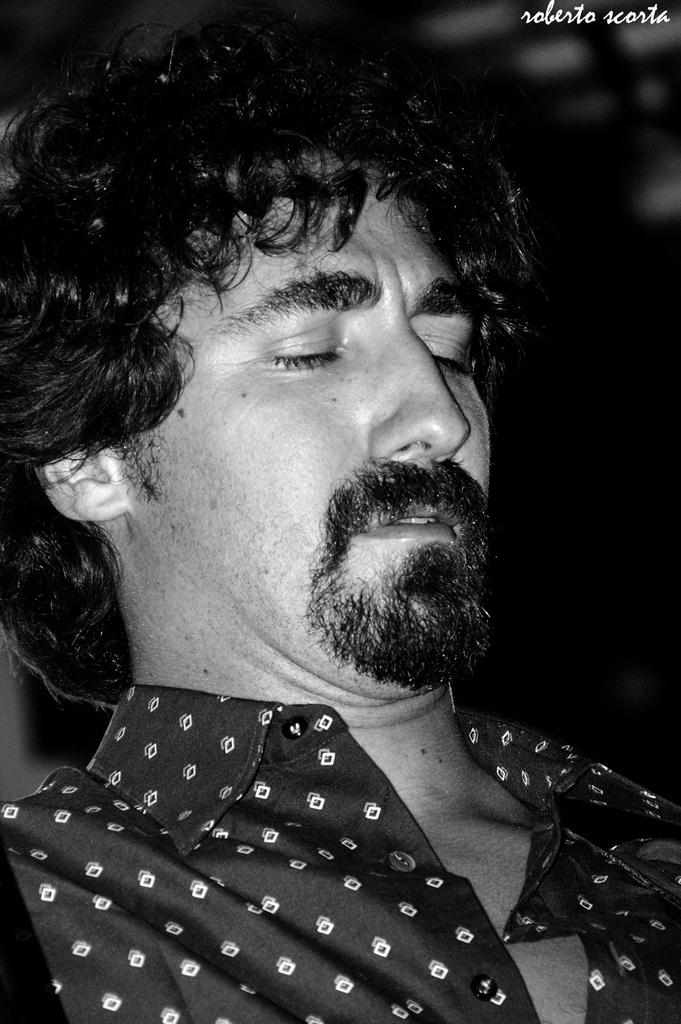Who is present in the image? There is a man in the image. What is the man wearing? The man is wearing a black shirt. How would you describe the overall lighting in the image? The background of the image appears dark. Can you identify any additional elements in the image? There is a watermark in the top right corner of the image. How many houses are visible in the image? There are no houses visible in the image; it features a man wearing a black shirt against a dark background with a watermark in the corner. 